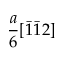<formula> <loc_0><loc_0><loc_500><loc_500>\frac { a } { 6 } [ \bar { 1 } \bar { 1 } 2 ]</formula> 